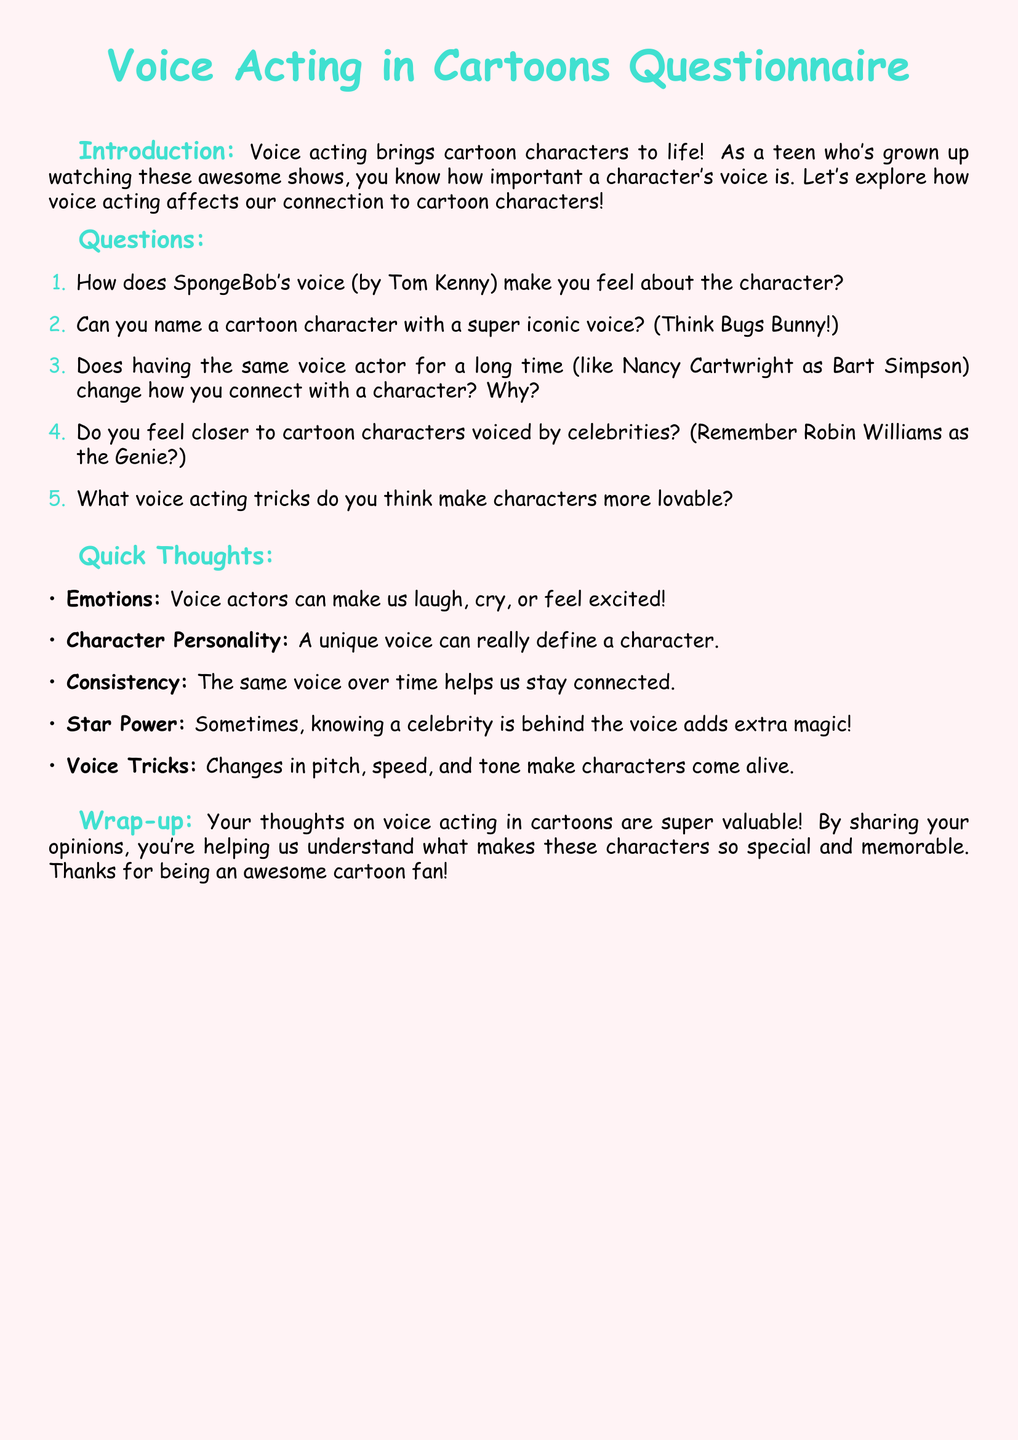What is the title of the questionnaire? The title is prominently displayed at the beginning of the document in large font.
Answer: Voice Acting in Cartoons Questionnaire Who voices SpongeBob? The document mentions the voice actor for SpongeBob directly in the questions section.
Answer: Tom Kenny Name a cartoon character with an iconic voice mentioned in the questionnaire. The questionnaire encourages naming iconic characters, leading to classic examples.
Answer: Bugs Bunny What profession is Nancy Cartwright known for in relation to the document? The document describes her long-term voice work for a specific character, which is referenced in the questions.
Answer: Voice actor What effect can a unique voice have on a character? The document suggests that a unique voice can influence the perception of characters significantly.
Answer: Define a character Which famous actor voiced the Genie in Aladdin? The questionnaire provides a specific example of a celebrity voice actor.
Answer: Robin Williams How many main topics are there in the Quick Thoughts section? The list in the Quick Thoughts section contains several points relating to voice acting.
Answer: Five What is a potential emotional response mentioned that voice actors can evoke? The document specifically mentions how voice actors can affect viewers' emotions directly.
Answer: Cry What do changes in pitch, speed, and tone do for characters? The document indicates that these vocal variations enhance character believability and connection.
Answer: Make characters come alive 